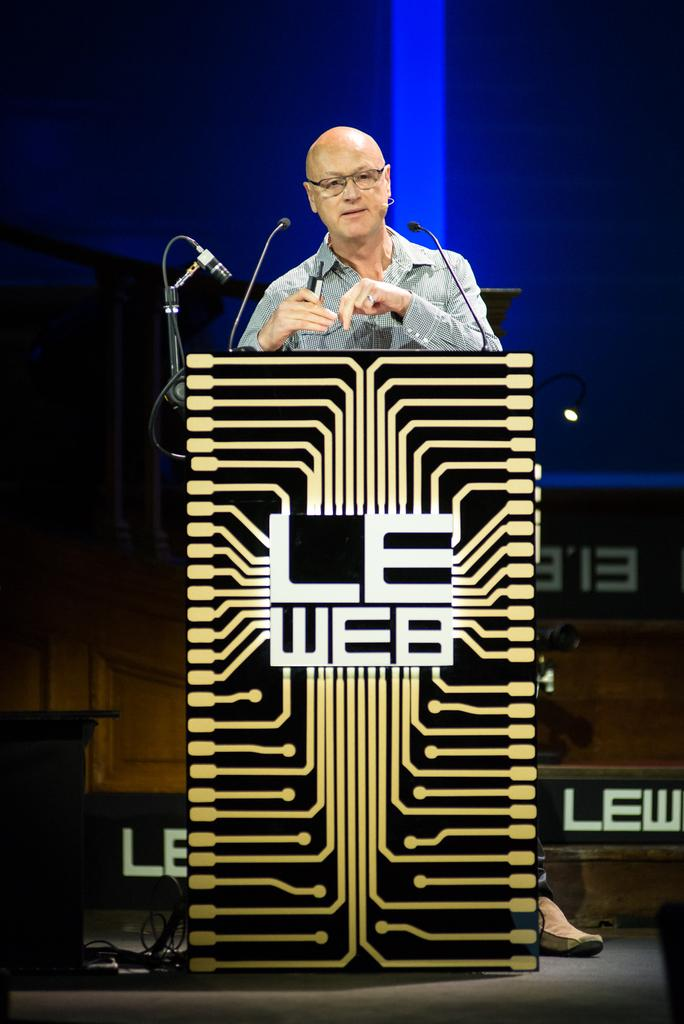What is the person in the image doing? The person is standing in front of a podium. What objects are present to aid in communication? There are microphones visible in the image. What color is the background of the image? The background of the image is blue. What type of straw is being used by the person in the image? There is no straw present in the image. Is the person wearing a scarf in the image? The image does not show the person wearing a scarf. 